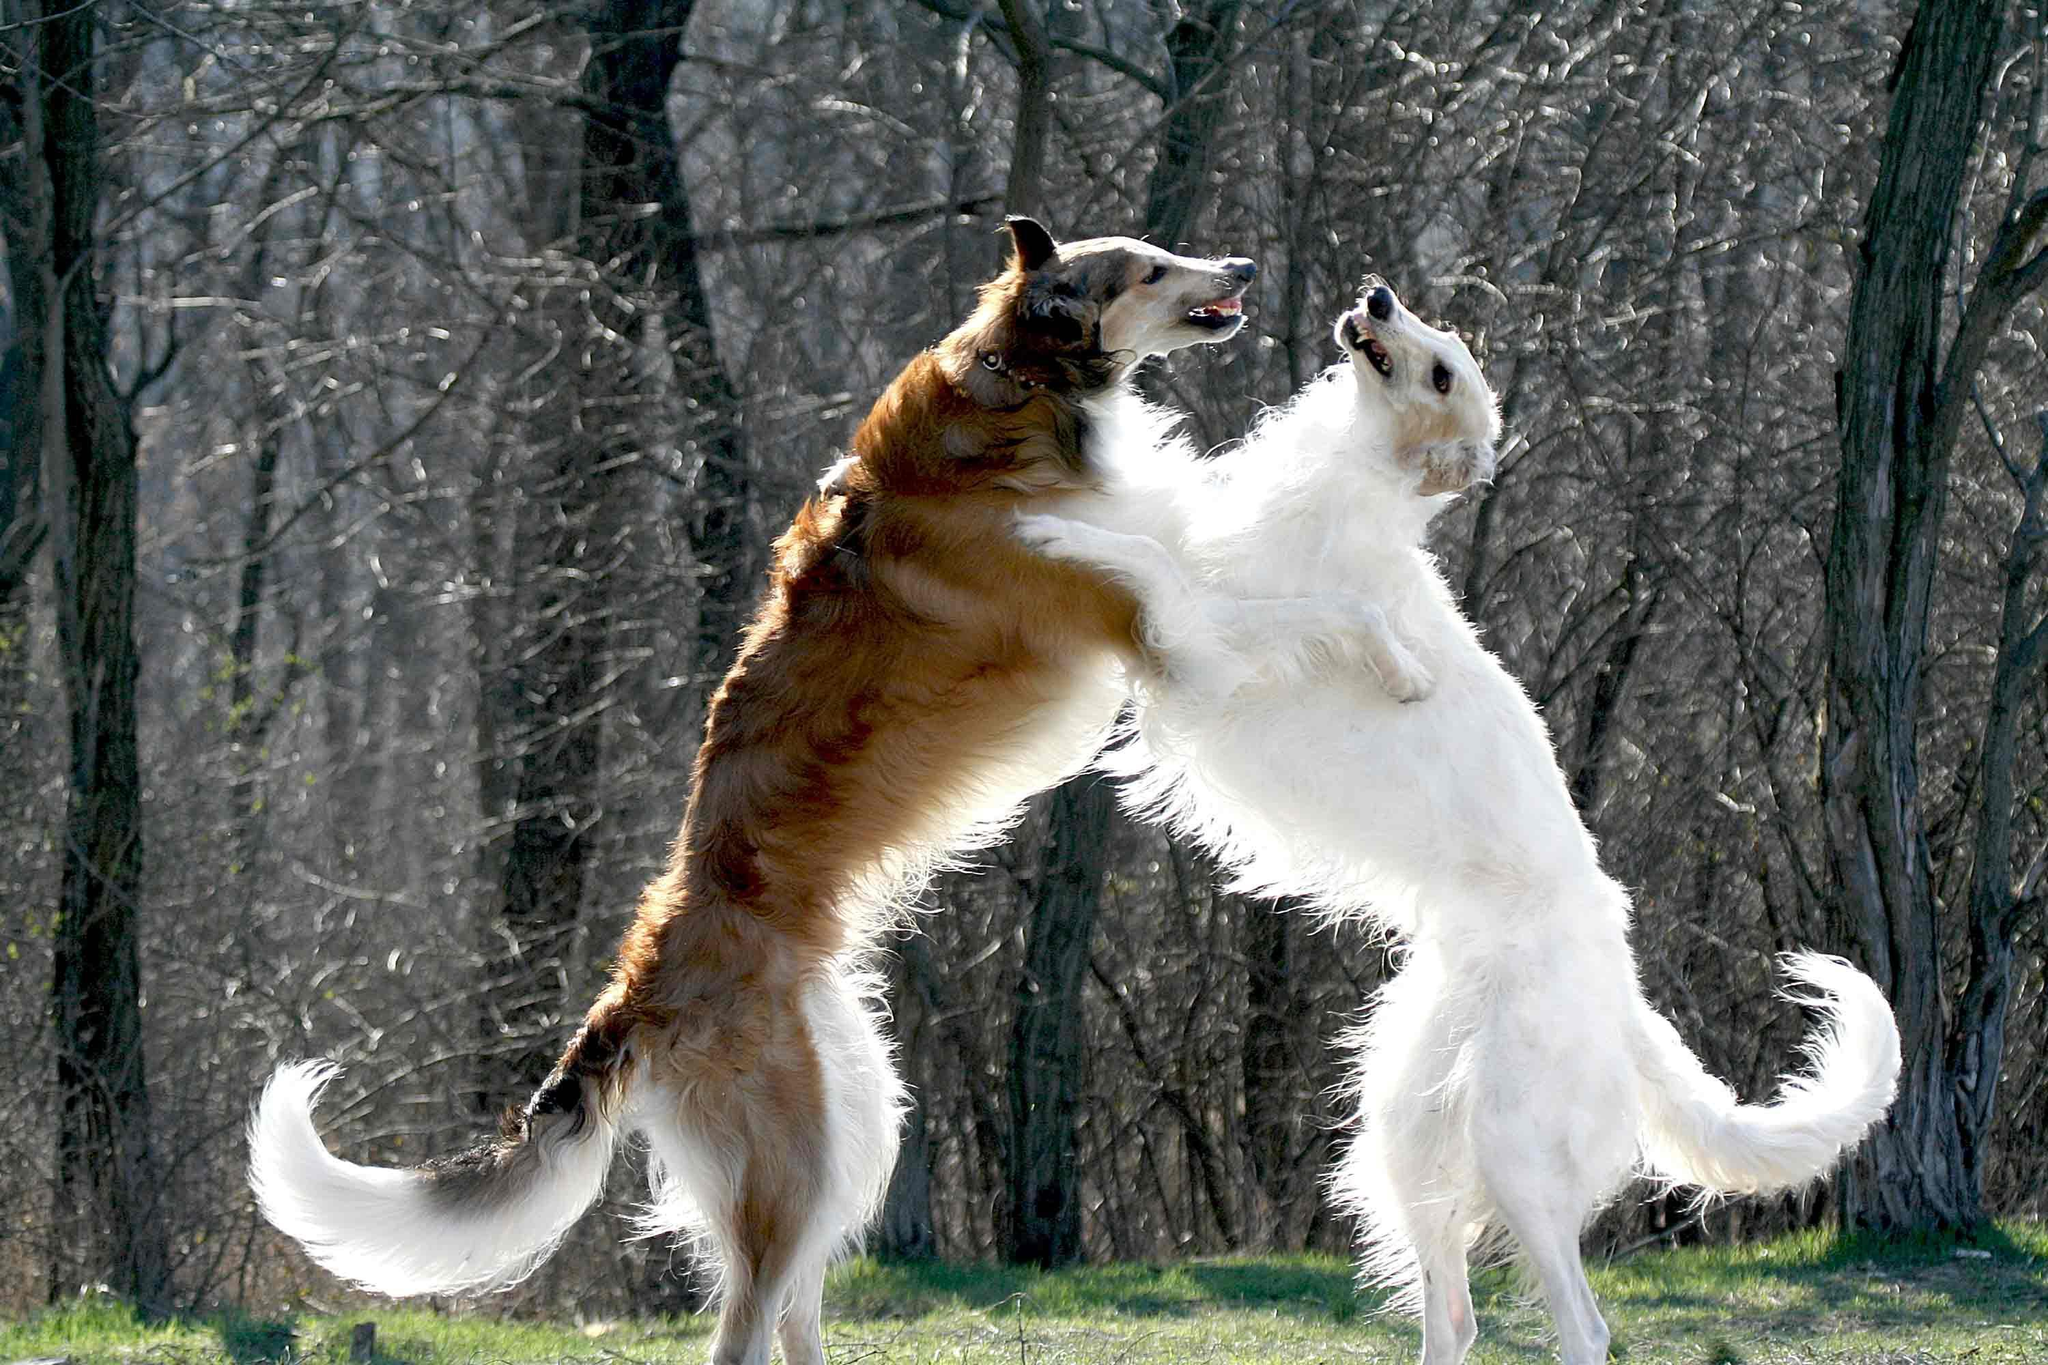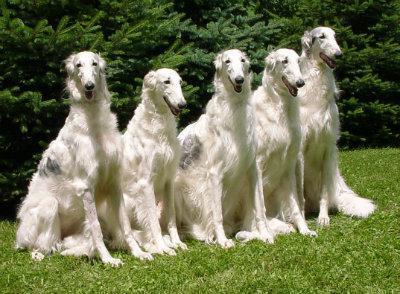The first image is the image on the left, the second image is the image on the right. For the images displayed, is the sentence "One images has two dogs fighting each other." factually correct? Answer yes or no. Yes. The first image is the image on the left, the second image is the image on the right. Analyze the images presented: Is the assertion "There is one image of two dogs that are actively playing together outside." valid? Answer yes or no. Yes. 